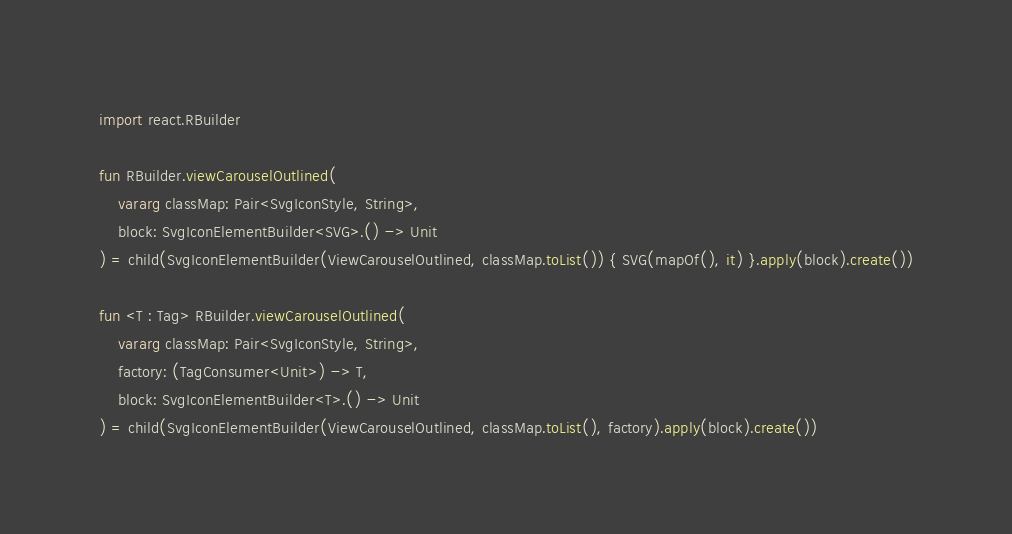Convert code to text. <code><loc_0><loc_0><loc_500><loc_500><_Kotlin_>import react.RBuilder

fun RBuilder.viewCarouselOutlined(
    vararg classMap: Pair<SvgIconStyle, String>,
    block: SvgIconElementBuilder<SVG>.() -> Unit
) = child(SvgIconElementBuilder(ViewCarouselOutlined, classMap.toList()) { SVG(mapOf(), it) }.apply(block).create())

fun <T : Tag> RBuilder.viewCarouselOutlined(
    vararg classMap: Pair<SvgIconStyle, String>,
    factory: (TagConsumer<Unit>) -> T,
    block: SvgIconElementBuilder<T>.() -> Unit
) = child(SvgIconElementBuilder(ViewCarouselOutlined, classMap.toList(), factory).apply(block).create())
</code> 